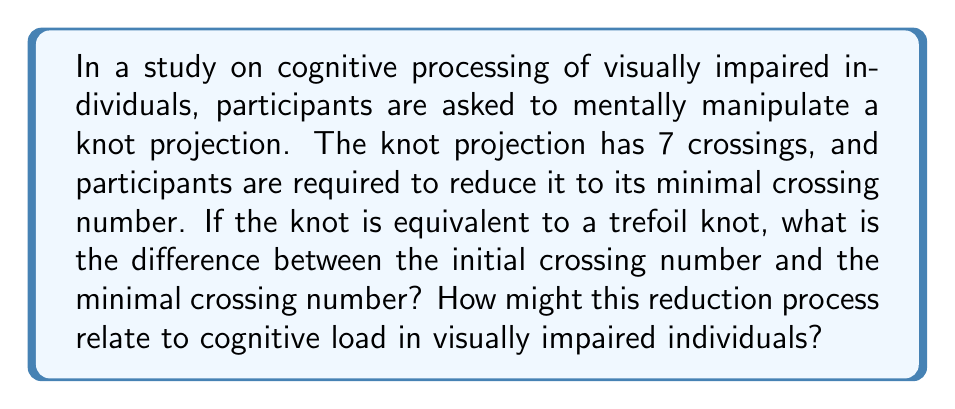Give your solution to this math problem. To solve this problem, we need to follow these steps:

1. Understand the given information:
   - Initial crossing number: 7
   - The knot is equivalent to a trefoil knot

2. Recall the properties of a trefoil knot:
   - A trefoil knot has a minimal crossing number of 3
   - This is the simplest non-trivial knot

3. Calculate the difference:
   $$\text{Difference} = \text{Initial crossing number} - \text{Minimal crossing number}$$
   $$\text{Difference} = 7 - 3 = 4$$

4. Interpret the result in terms of cognitive processing:
   - The reduction from 7 crossings to 3 crossings represents a simplification process
   - This process requires mental manipulation and visualization of the knot
   - For visually impaired individuals, this task may impose a higher cognitive load due to:
     a) Reliance on tactile or auditory cues instead of visual information
     b) Increased demand on working memory to maintain and manipulate the knot representation
     c) Potential need for alternative strategies to compensate for lack of visual input

5. The difference of 4 crossings represents the extent of simplification required, which can be used as a measure of task complexity in cognitive studies.
Answer: 4 crossings 